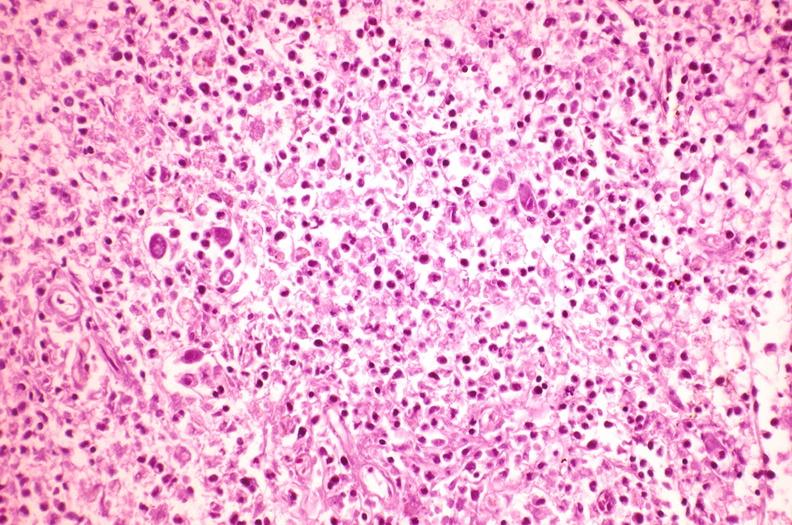what is present?
Answer the question using a single word or phrase. Hematologic 